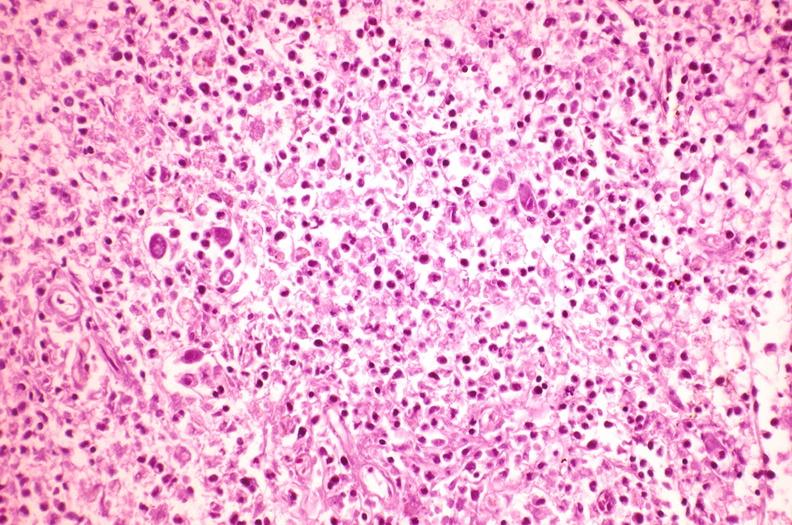what is present?
Answer the question using a single word or phrase. Hematologic 